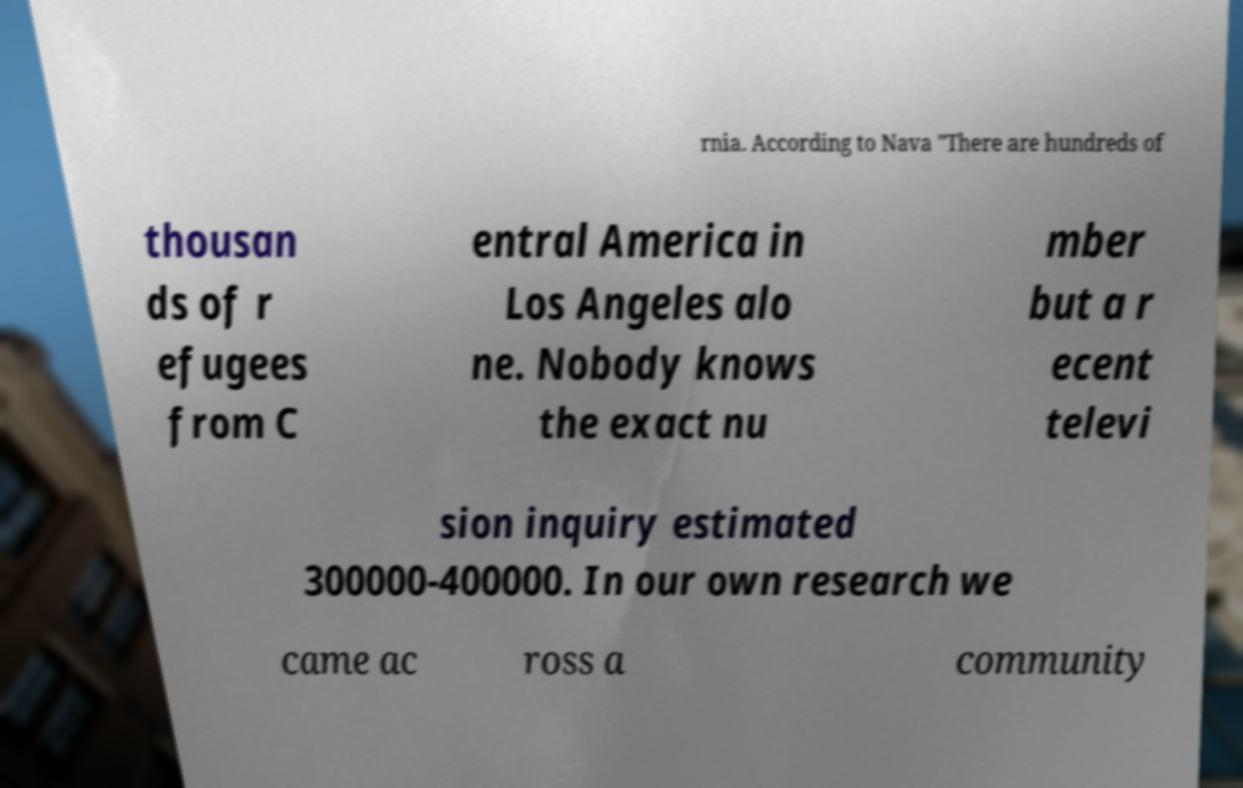Could you assist in decoding the text presented in this image and type it out clearly? rnia. According to Nava "There are hundreds of thousan ds of r efugees from C entral America in Los Angeles alo ne. Nobody knows the exact nu mber but a r ecent televi sion inquiry estimated 300000-400000. In our own research we came ac ross a community 